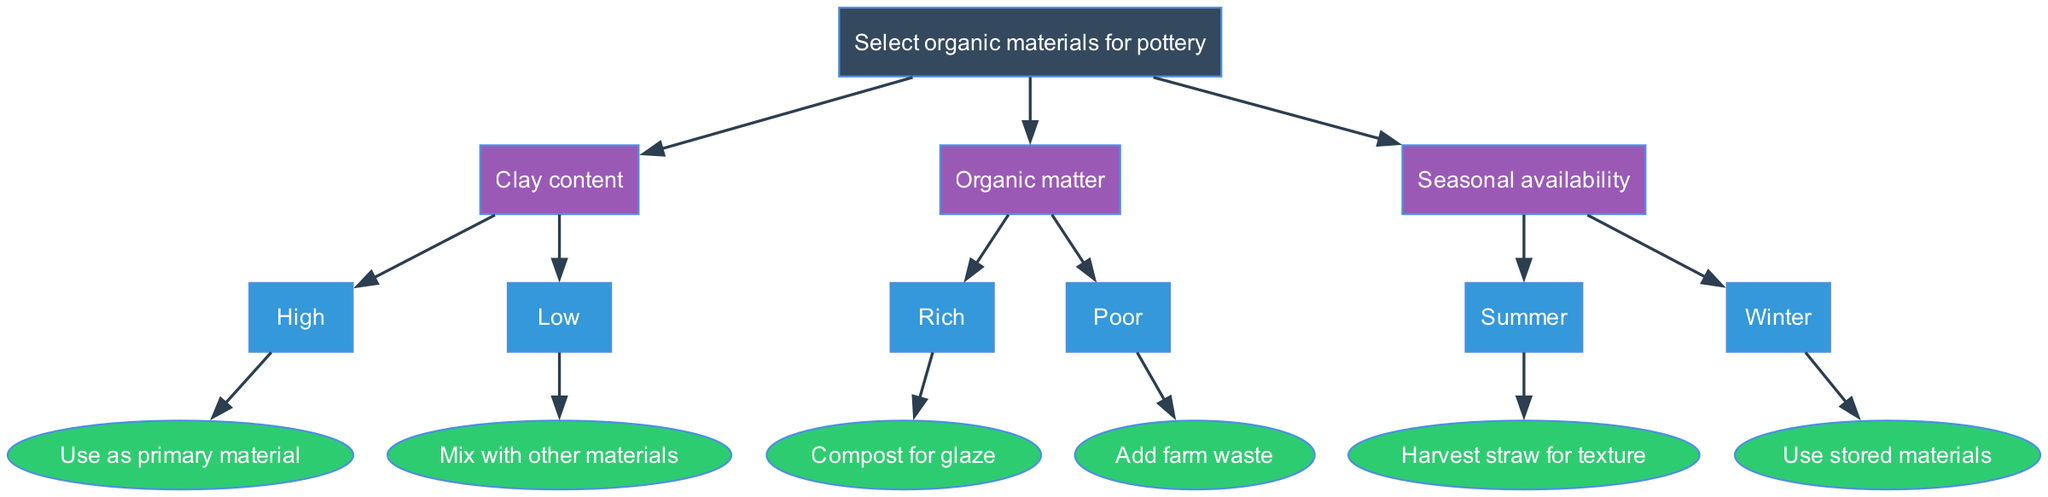What is the root node of the diagram? The root node is the starting point of the decision tree, which is labeled "Select organic materials for pottery".
Answer: Select organic materials for pottery How many main nodes are in the diagram? There are three main nodes branching from the root node: "Clay content", "Organic matter", and "Seasonal availability".
Answer: 3 What happens if the clay content is low? The diagram indicates that if clay content is low, the next action is to "Mix with other materials".
Answer: Mix with other materials What is the action to be taken if organic matter is rich? According to the diagram, if organic matter is rich, the action is to "Compost for glaze".
Answer: Compost for glaze What is the recommendation for seasonal availability in summer? The diagram suggests that during summer, the appropriate action is to "Harvest straw for texture".
Answer: Harvest straw for texture If the clay content is high, what is the next step? When the clay content is high, the decision tree directs to "Use as primary material".
Answer: Use as primary material What is the output if organic matter is poor? If organic matter is poor, the next step is to "Add farm waste".
Answer: Add farm waste In which season should you use stored materials? The diagram specifies using stored materials in the winter season.
Answer: Winter What is the relationship between clay content and how to use it? The relationship shows that high clay content leads to using it as a primary material, whereas low clay content suggests mixing it with other materials.
Answer: High: Use as primary material; Low: Mix with other materials What type of diagram is this? This diagram is a decision tree, which is structured to depict choices based on different conditions like soil composition and availability of organic materials.
Answer: Decision tree 